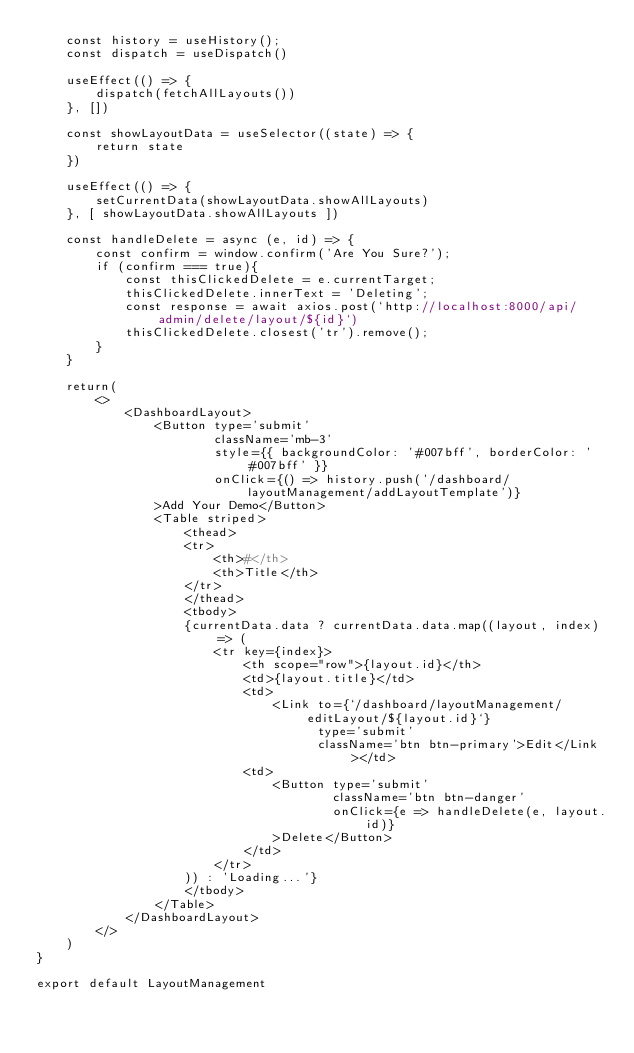Convert code to text. <code><loc_0><loc_0><loc_500><loc_500><_JavaScript_>    const history = useHistory();
    const dispatch = useDispatch()

    useEffect(() => {
        dispatch(fetchAllLayouts())
    }, [])

    const showLayoutData = useSelector((state) => {
        return state
    })

    useEffect(() => {
        setCurrentData(showLayoutData.showAllLayouts)
    }, [ showLayoutData.showAllLayouts ])

    const handleDelete = async (e, id) => {
        const confirm = window.confirm('Are You Sure?');
        if (confirm === true){
            const thisClickedDelete = e.currentTarget;
            thisClickedDelete.innerText = 'Deleting';
            const response = await axios.post(`http://localhost:8000/api/admin/delete/layout/${id}`)
            thisClickedDelete.closest('tr').remove();
        }
    }

    return(
        <>
            <DashboardLayout>
                <Button type='submit'
                        className='mb-3'
                        style={{ backgroundColor: '#007bff', borderColor: '#007bff' }}
                        onClick={() => history.push('/dashboard/layoutManagement/addLayoutTemplate')}
                >Add Your Demo</Button>
                <Table striped>
                    <thead>
                    <tr>
                        <th>#</th>
                        <th>Title</th>
                    </tr>
                    </thead>
                    <tbody>
                    {currentData.data ? currentData.data.map((layout, index) => (
                        <tr key={index}>
                            <th scope="row">{layout.id}</th>
                            <td>{layout.title}</td>
                            <td>
                                <Link to={`/dashboard/layoutManagement/editLayout/${layout.id}`}
                                      type='submit'
                                      className='btn btn-primary'>Edit</Link></td>
                            <td>
                                <Button type='submit'
                                        className='btn btn-danger'
                                        onClick={e => handleDelete(e, layout.id)}
                                >Delete</Button>
                            </td>
                        </tr>
                    )) : 'Loading...'}
                    </tbody>
                </Table>
            </DashboardLayout>
        </>
    )
}

export default LayoutManagement
</code> 